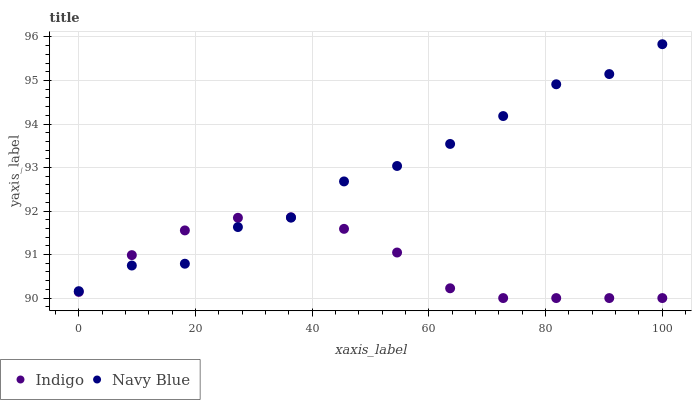Does Indigo have the minimum area under the curve?
Answer yes or no. Yes. Does Navy Blue have the maximum area under the curve?
Answer yes or no. Yes. Does Indigo have the maximum area under the curve?
Answer yes or no. No. Is Indigo the smoothest?
Answer yes or no. Yes. Is Navy Blue the roughest?
Answer yes or no. Yes. Is Indigo the roughest?
Answer yes or no. No. Does Indigo have the lowest value?
Answer yes or no. Yes. Does Navy Blue have the highest value?
Answer yes or no. Yes. Does Indigo have the highest value?
Answer yes or no. No. Does Indigo intersect Navy Blue?
Answer yes or no. Yes. Is Indigo less than Navy Blue?
Answer yes or no. No. Is Indigo greater than Navy Blue?
Answer yes or no. No. 